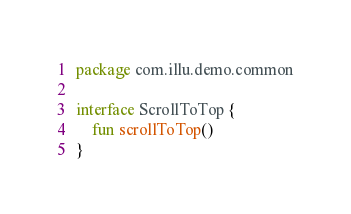Convert code to text. <code><loc_0><loc_0><loc_500><loc_500><_Kotlin_>package com.illu.demo.common

interface ScrollToTop {
    fun scrollToTop()
}</code> 